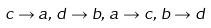Convert formula to latex. <formula><loc_0><loc_0><loc_500><loc_500>c \rightarrow a , \, d \rightarrow b , \, a \rightarrow c , \, b \rightarrow d</formula> 